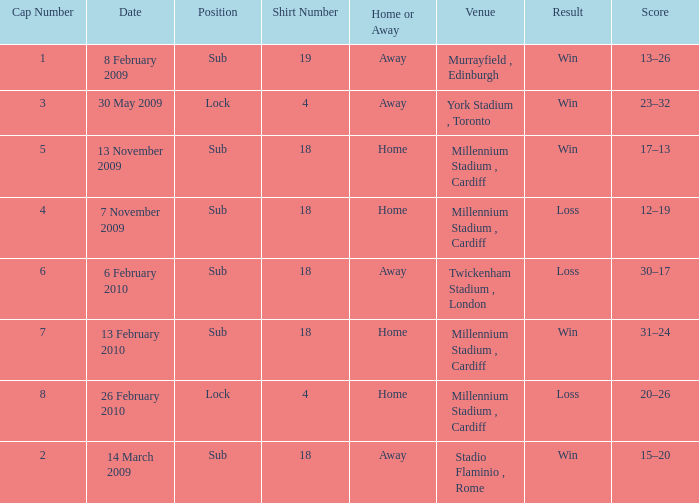Can you tell me the lowest Cap Number that has the Date of 8 february 2009, and the Shirt Number larger than 19? None. Could you parse the entire table as a dict? {'header': ['Cap Number', 'Date', 'Position', 'Shirt Number', 'Home or Away', 'Venue', 'Result', 'Score'], 'rows': [['1', '8 February 2009', 'Sub', '19', 'Away', 'Murrayfield , Edinburgh', 'Win', '13–26'], ['3', '30 May 2009', 'Lock', '4', 'Away', 'York Stadium , Toronto', 'Win', '23–32'], ['5', '13 November 2009', 'Sub', '18', 'Home', 'Millennium Stadium , Cardiff', 'Win', '17–13'], ['4', '7 November 2009', 'Sub', '18', 'Home', 'Millennium Stadium , Cardiff', 'Loss', '12–19'], ['6', '6 February 2010', 'Sub', '18', 'Away', 'Twickenham Stadium , London', 'Loss', '30–17'], ['7', '13 February 2010', 'Sub', '18', 'Home', 'Millennium Stadium , Cardiff', 'Win', '31–24'], ['8', '26 February 2010', 'Lock', '4', 'Home', 'Millennium Stadium , Cardiff', 'Loss', '20–26'], ['2', '14 March 2009', 'Sub', '18', 'Away', 'Stadio Flaminio , Rome', 'Win', '15–20']]} 